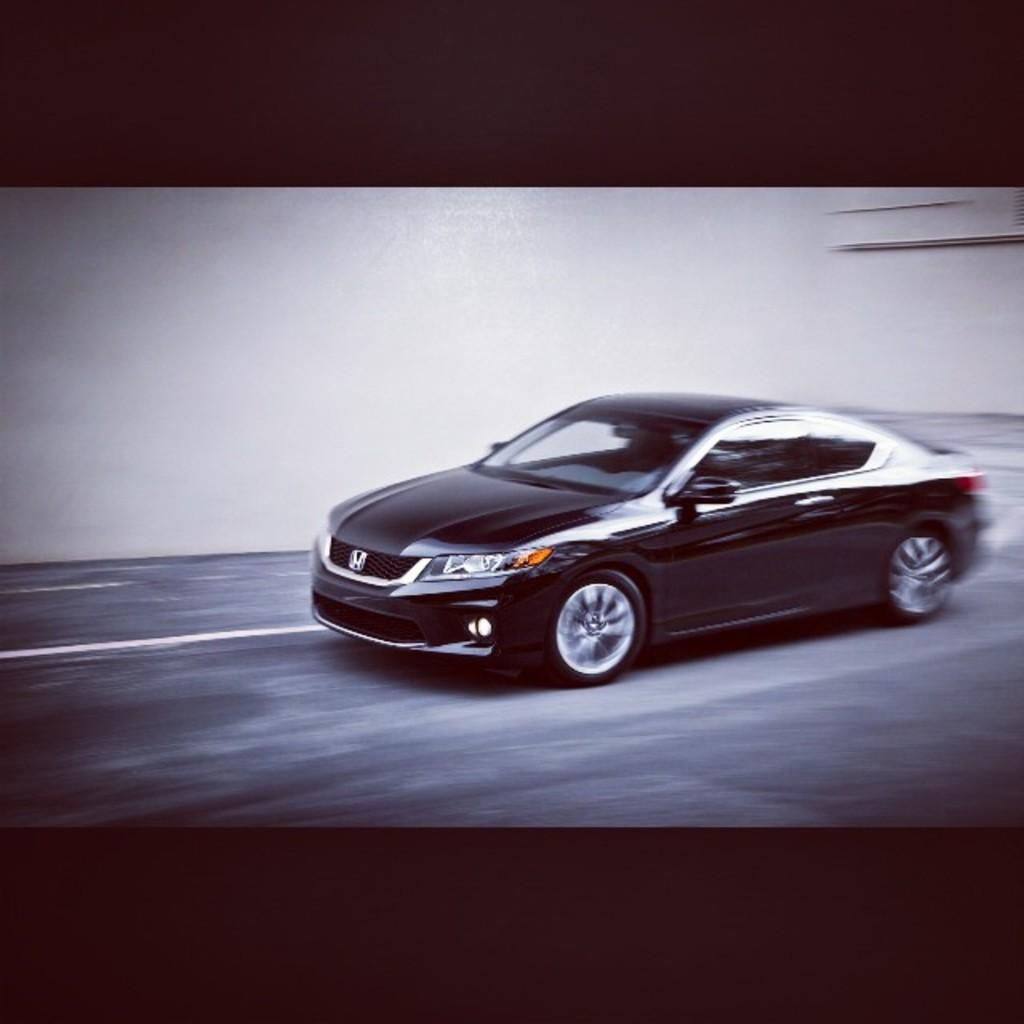What is the main subject of the image? The main subject of the image is a car. Can you describe the car's appearance? The car is black in color. Where is the car located in the image? The car is on the road. What can be seen in the background of the image? There is a wall in the background of the image. What is the color of the wall? The wall is white in color. How many pairs of shoes can be seen on the car in the image? There are no shoes visible on the car in the image. What type of process is being depicted in the image? The image does not depict any process; it simply shows a black car on the road with a white wall in the background. 